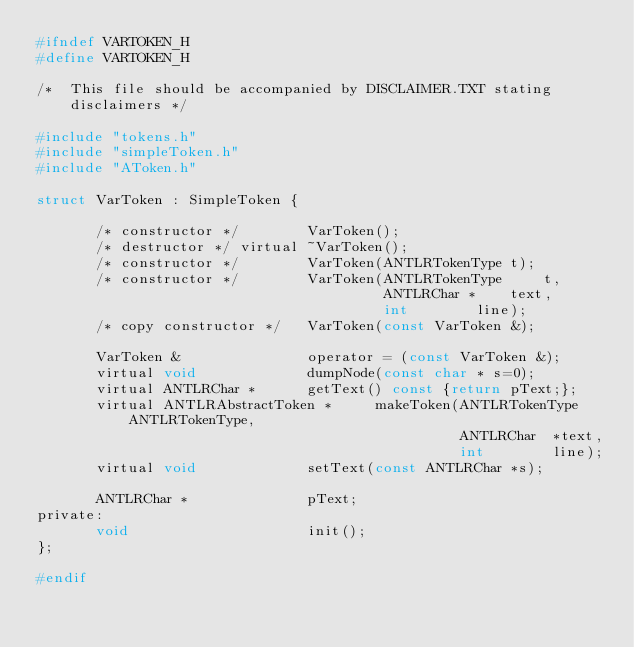<code> <loc_0><loc_0><loc_500><loc_500><_C_>#ifndef VARTOKEN_H
#define VARTOKEN_H

/*  This file should be accompanied by DISCLAIMER.TXT stating disclaimers */

#include "tokens.h"
#include "simpleToken.h"
#include "AToken.h"

struct VarToken : SimpleToken {

       /* constructor */		VarToken();
       /* destructor */ virtual	~VarToken();
       /* constructor */		VarToken(ANTLRTokenType t);
       /* constructor */		VarToken(ANTLRTokenType 	t,
    					                 ANTLRChar *	text,
					                     int		line);
       /* copy constructor */	VarToken(const VarToken &);

       VarToken &			    operator = (const VarToken &);
       virtual void	          	dumpNode(const char * s=0);
       virtual ANTLRChar * 		getText() const {return pText;};
       virtual ANTLRAbstractToken *     makeToken(ANTLRTokenType ANTLRTokenType,
					                              ANTLRChar	 *text,
					                              int		 line);
       virtual void 			setText(const ANTLRChar *s);

       ANTLRChar *  			pText;
private:
       void			        	init();
};

#endif
</code> 